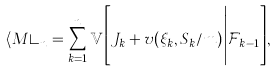Convert formula to latex. <formula><loc_0><loc_0><loc_500><loc_500>\langle M \rangle _ { n } = \sum _ { k = 1 } ^ { n } { \mathbb { V } } \Big [ J _ { k } + v ( \xi _ { k } , S _ { k } / m ) \Big | { \mathcal { F } } _ { k - 1 } \Big ] ,</formula> 